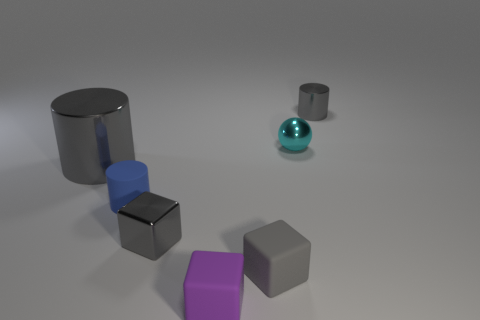Subtract all gray cylinders. How many cylinders are left? 1 Add 1 cyan metal blocks. How many objects exist? 8 Subtract all balls. How many objects are left? 6 Add 3 tiny matte cubes. How many tiny matte cubes exist? 5 Subtract 1 purple blocks. How many objects are left? 6 Subtract all big cylinders. Subtract all purple matte blocks. How many objects are left? 5 Add 2 tiny gray metal objects. How many tiny gray metal objects are left? 4 